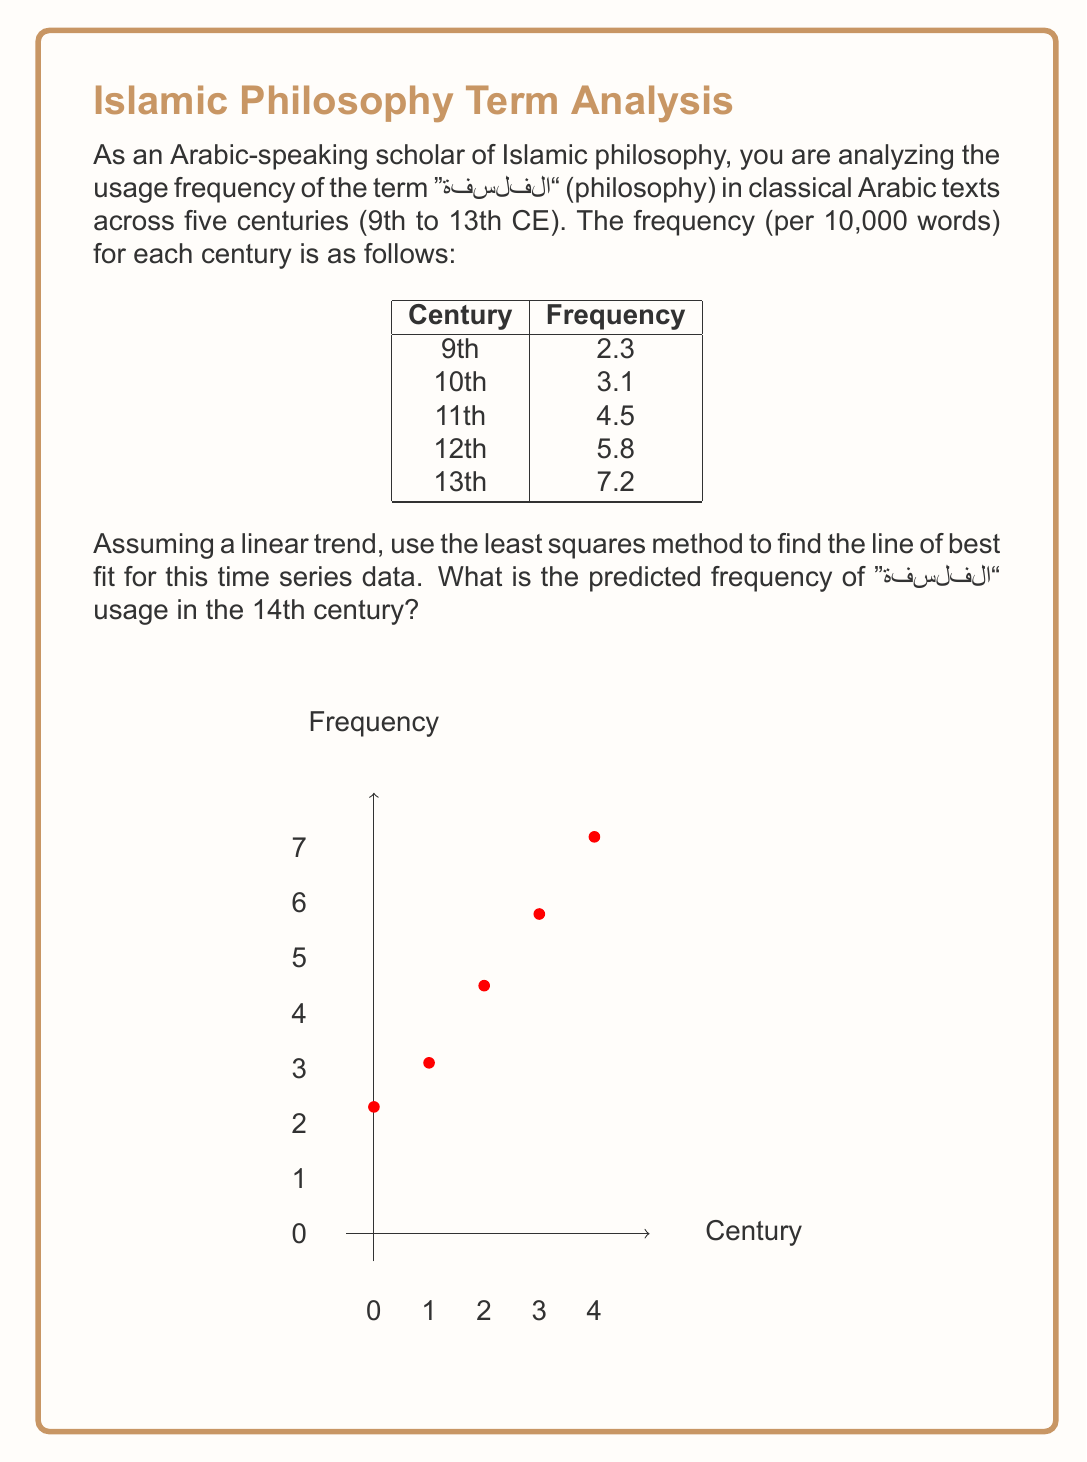Solve this math problem. To find the line of best fit using the least squares method, we need to calculate the slope (m) and y-intercept (b) of the line y = mx + b.

Let's define our variables:
x: centuries (0 for 9th, 1 for 10th, ..., 4 for 13th)
y: frequency of "الفلسفة" usage

Step 1: Calculate the means of x and y
$$\bar{x} = \frac{0 + 1 + 2 + 3 + 4}{5} = 2$$
$$\bar{y} = \frac{2.3 + 3.1 + 4.5 + 5.8 + 7.2}{5} = 4.58$$

Step 2: Calculate the slope (m)
$$m = \frac{\sum(x_i - \bar{x})(y_i - \bar{y})}{\sum(x_i - \bar{x})^2}$$

$$\sum(x_i - \bar{x})(y_i - \bar{y}) = (-2)(-2.28) + (-1)(-1.48) + (0)(-0.08) + (1)(1.22) + (2)(2.62) = 11.6$$
$$\sum(x_i - \bar{x})^2 = (-2)^2 + (-1)^2 + 0^2 + 1^2 + 2^2 = 10$$

$$m = \frac{11.6}{10} = 1.16$$

Step 3: Calculate the y-intercept (b)
$$b = \bar{y} - m\bar{x} = 4.58 - 1.16(2) = 2.26$$

Step 4: Write the equation of the line of best fit
$$y = 1.16x + 2.26$$

Step 5: Predict the frequency for the 14th century (x = 5)
$$y = 1.16(5) + 2.26 = 8.06$$

Therefore, the predicted frequency of "الفلسفة" usage in the 14th century is 8.06 per 10,000 words.
Answer: 8.06 